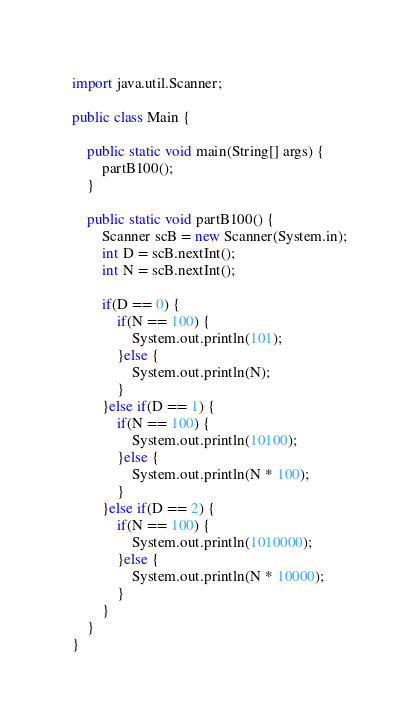Convert code to text. <code><loc_0><loc_0><loc_500><loc_500><_Java_>import java.util.Scanner;

public class Main {

	public static void main(String[] args) {
		partB100();
	}
	
	public static void partB100() {
		Scanner scB = new Scanner(System.in);
		int D = scB.nextInt();
		int N = scB.nextInt();

		if(D == 0) {
			if(N == 100) {
				System.out.println(101);
			}else {
				System.out.println(N);
			}
		}else if(D == 1) {
			if(N == 100) {
				System.out.println(10100);
			}else {
				System.out.println(N * 100);
			}
		}else if(D == 2) {
			if(N == 100) {
				System.out.println(1010000);
			}else {
				System.out.println(N * 10000);
			}
		}
	}
}</code> 